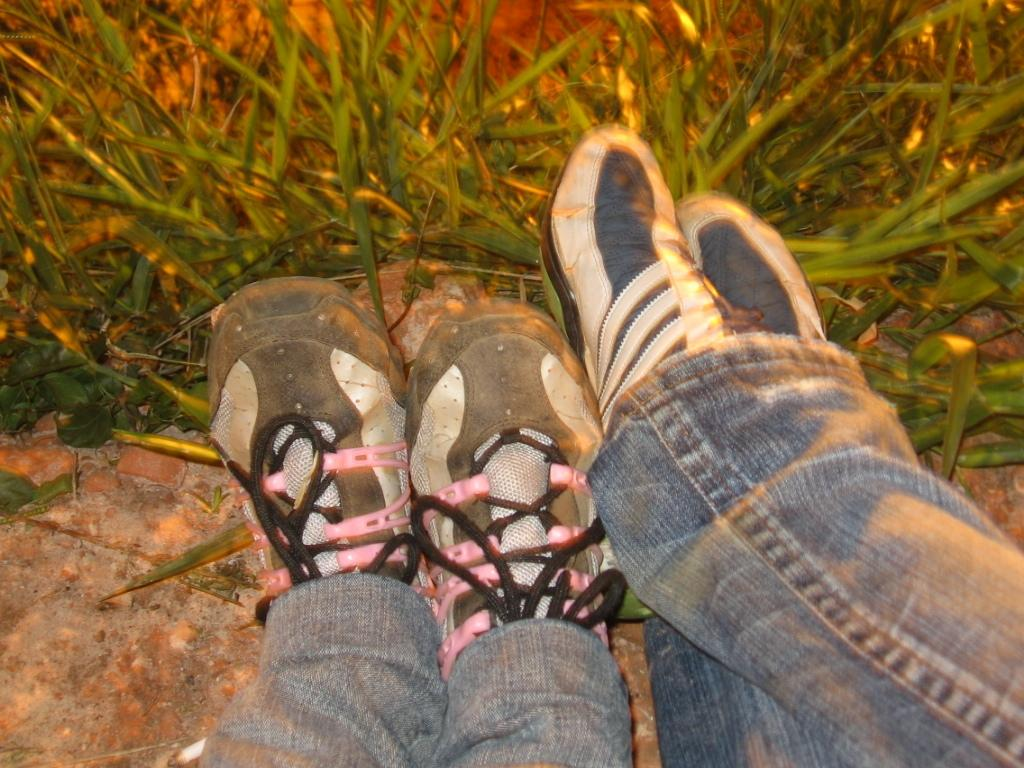How many people are in the image? There are two persons in the image. What are the people wearing on their feet? Both persons are wearing shoes. What type of ground surface is visible in the image? There is grass visible in the image. What type of beef is being cooked on the range in the image? There is no beef or range present in the image; it features two persons wearing shoes and grass in the background. 